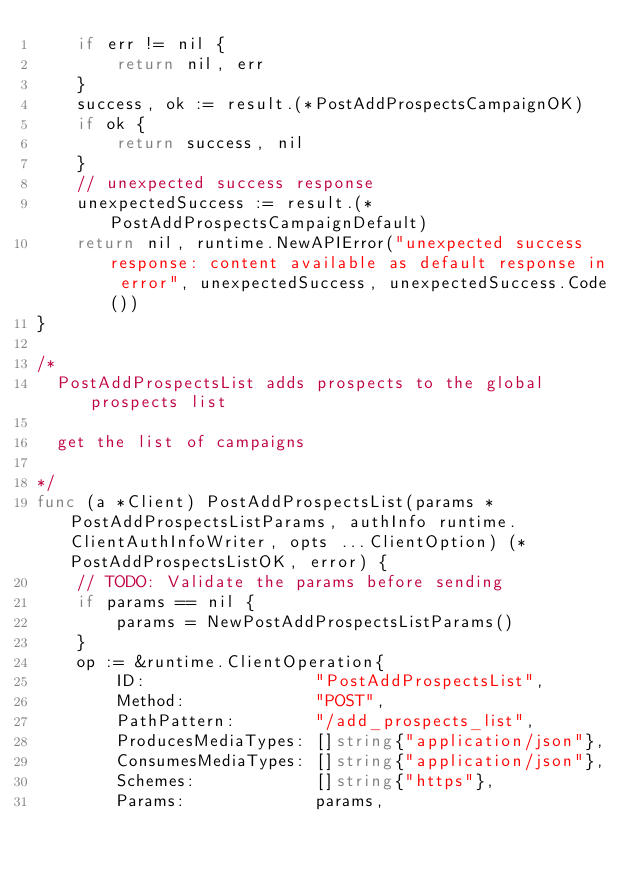<code> <loc_0><loc_0><loc_500><loc_500><_Go_>	if err != nil {
		return nil, err
	}
	success, ok := result.(*PostAddProspectsCampaignOK)
	if ok {
		return success, nil
	}
	// unexpected success response
	unexpectedSuccess := result.(*PostAddProspectsCampaignDefault)
	return nil, runtime.NewAPIError("unexpected success response: content available as default response in error", unexpectedSuccess, unexpectedSuccess.Code())
}

/*
  PostAddProspectsList adds prospects to the global prospects list

  get the list of campaigns

*/
func (a *Client) PostAddProspectsList(params *PostAddProspectsListParams, authInfo runtime.ClientAuthInfoWriter, opts ...ClientOption) (*PostAddProspectsListOK, error) {
	// TODO: Validate the params before sending
	if params == nil {
		params = NewPostAddProspectsListParams()
	}
	op := &runtime.ClientOperation{
		ID:                 "PostAddProspectsList",
		Method:             "POST",
		PathPattern:        "/add_prospects_list",
		ProducesMediaTypes: []string{"application/json"},
		ConsumesMediaTypes: []string{"application/json"},
		Schemes:            []string{"https"},
		Params:             params,</code> 